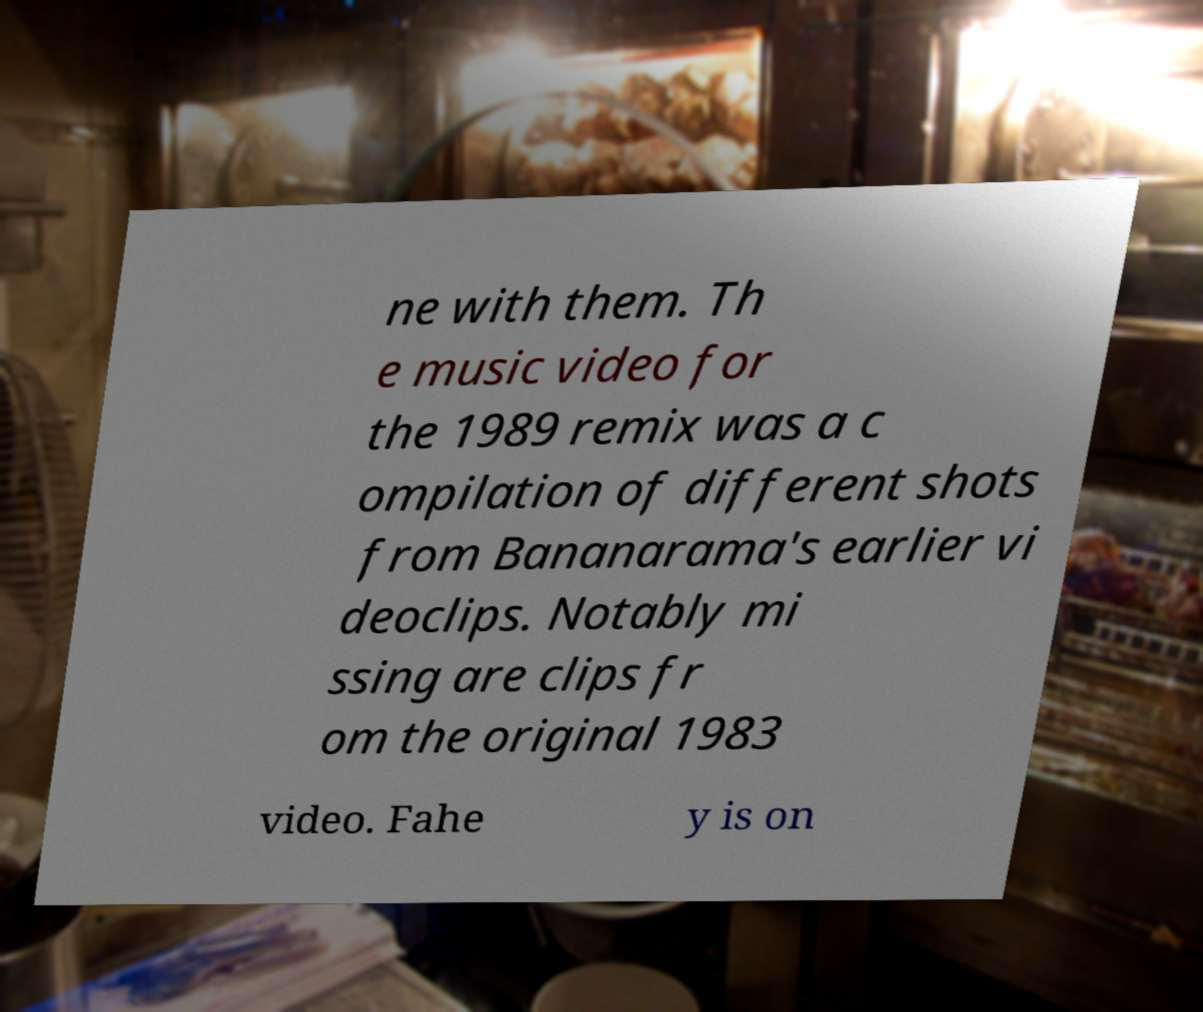Please read and relay the text visible in this image. What does it say? ne with them. Th e music video for the 1989 remix was a c ompilation of different shots from Bananarama's earlier vi deoclips. Notably mi ssing are clips fr om the original 1983 video. Fahe y is on 